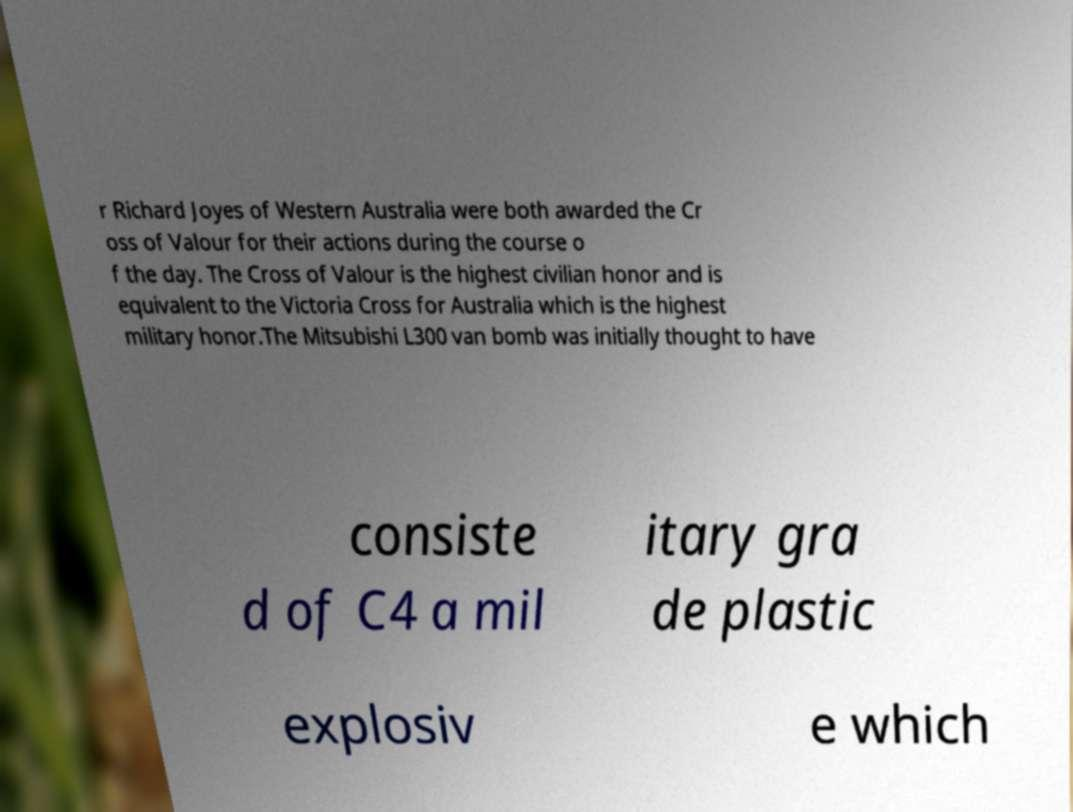Can you read and provide the text displayed in the image?This photo seems to have some interesting text. Can you extract and type it out for me? r Richard Joyes of Western Australia were both awarded the Cr oss of Valour for their actions during the course o f the day. The Cross of Valour is the highest civilian honor and is equivalent to the Victoria Cross for Australia which is the highest military honor.The Mitsubishi L300 van bomb was initially thought to have consiste d of C4 a mil itary gra de plastic explosiv e which 